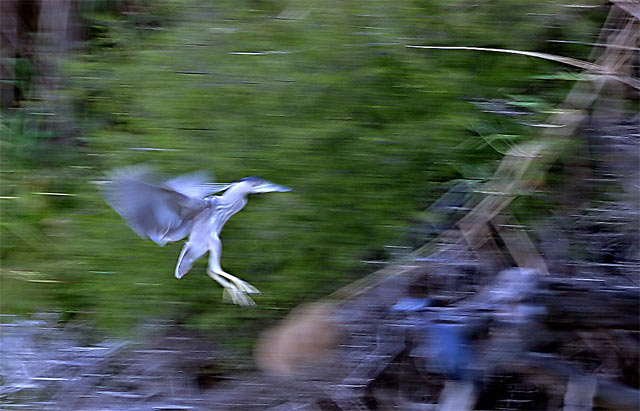What is the main subject of this photograph? The main subject of the photograph is a bird, captured in mid-flight with its wings spread. The motion blur suggests rapid movement and a fleeting moment caught on camera. 